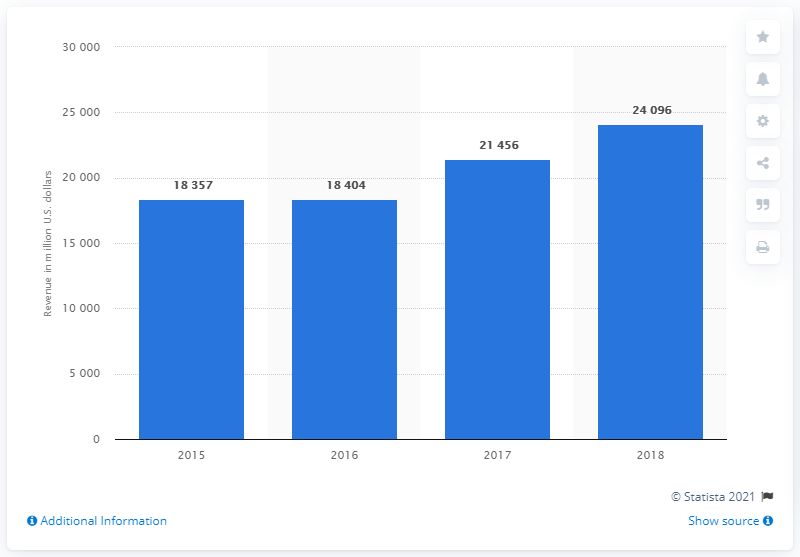Point out several critical features in this image. In 2018, the Packaging & Specialty Plastics segment of DowDuPont generated a total revenue of approximately 24,096. 